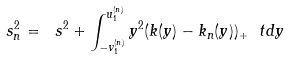Convert formula to latex. <formula><loc_0><loc_0><loc_500><loc_500>\ s ^ { 2 } _ { n } = \ s ^ { 2 } + \int _ { - v ^ { ( n ) } _ { 1 } } ^ { u ^ { ( n ) } _ { 1 } } y ^ { 2 } ( k ( y ) - k _ { n } ( y ) ) _ { + } \ t d y</formula> 